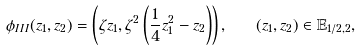<formula> <loc_0><loc_0><loc_500><loc_500>\phi _ { I I I } ( z _ { 1 } , z _ { 2 } ) = \left ( \zeta z _ { 1 } , \zeta ^ { 2 } \left ( \frac { 1 } { 4 } z _ { 1 } ^ { 2 } - z _ { 2 } \right ) \right ) , \quad ( z _ { 1 } , z _ { 2 } ) \in \mathbb { E } _ { 1 / 2 , 2 } ,</formula> 